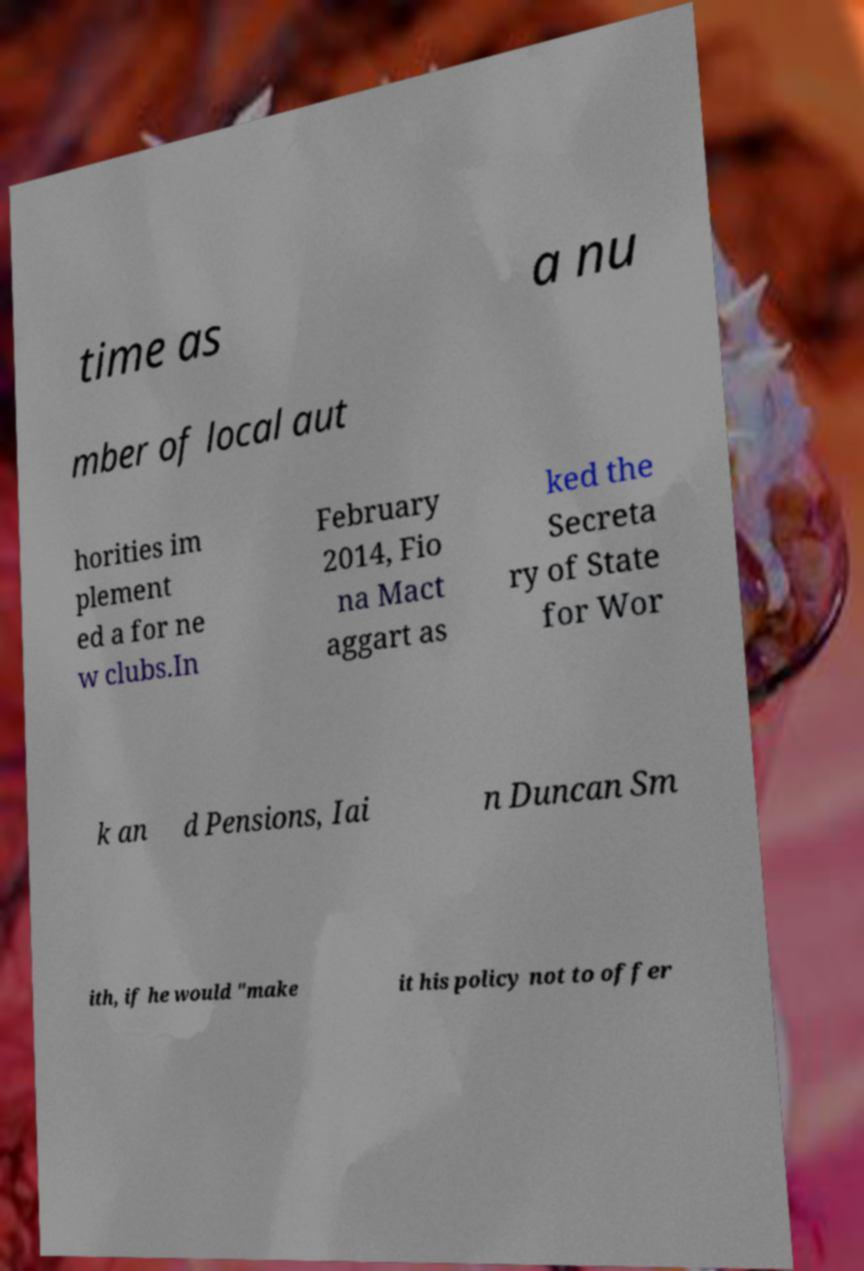There's text embedded in this image that I need extracted. Can you transcribe it verbatim? time as a nu mber of local aut horities im plement ed a for ne w clubs.In February 2014, Fio na Mact aggart as ked the Secreta ry of State for Wor k an d Pensions, Iai n Duncan Sm ith, if he would "make it his policy not to offer 